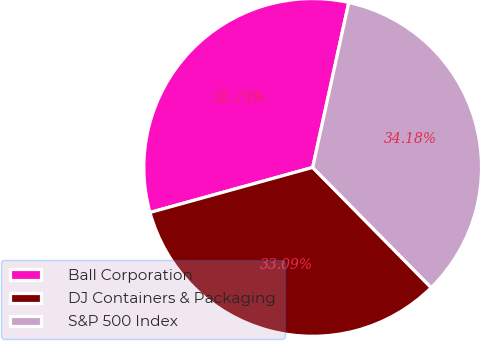<chart> <loc_0><loc_0><loc_500><loc_500><pie_chart><fcel>Ball Corporation<fcel>DJ Containers & Packaging<fcel>S&P 500 Index<nl><fcel>32.73%<fcel>33.09%<fcel>34.18%<nl></chart> 